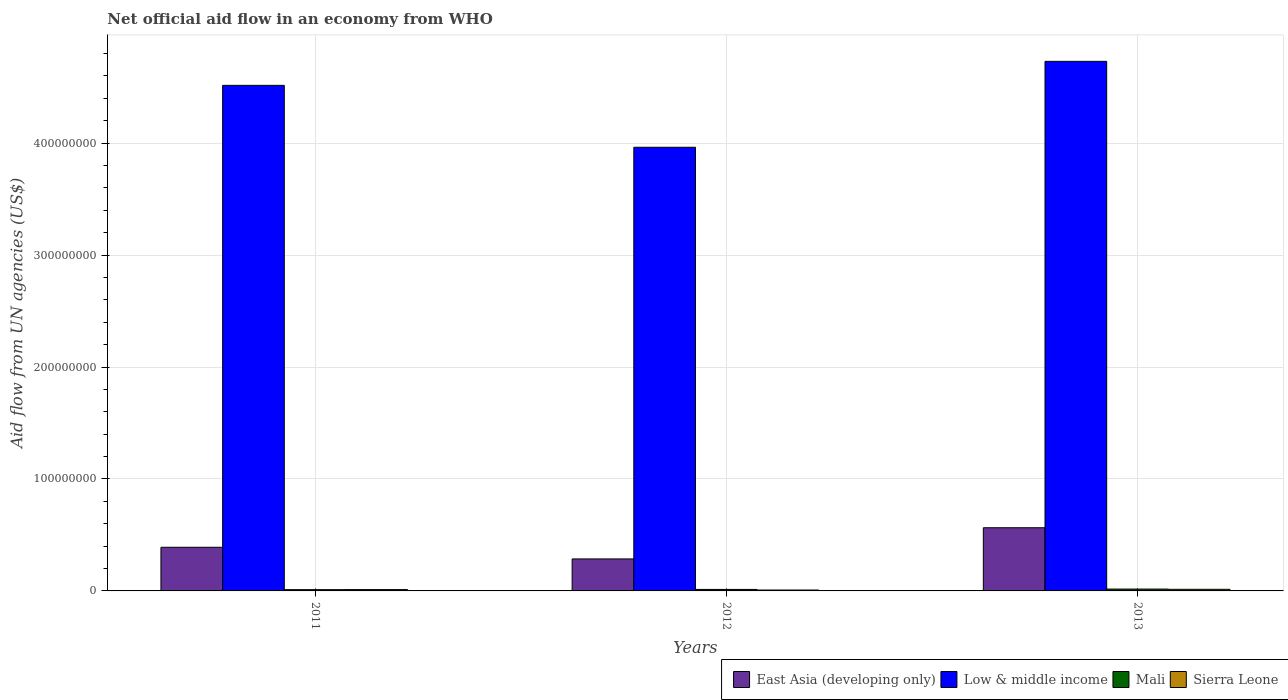How many groups of bars are there?
Keep it short and to the point. 3. Are the number of bars on each tick of the X-axis equal?
Keep it short and to the point. Yes. How many bars are there on the 3rd tick from the right?
Ensure brevity in your answer.  4. What is the label of the 2nd group of bars from the left?
Your response must be concise. 2012. What is the net official aid flow in Mali in 2012?
Make the answer very short. 1.33e+06. Across all years, what is the maximum net official aid flow in East Asia (developing only)?
Keep it short and to the point. 5.64e+07. Across all years, what is the minimum net official aid flow in Mali?
Provide a succinct answer. 1.13e+06. In which year was the net official aid flow in Sierra Leone maximum?
Provide a succinct answer. 2013. In which year was the net official aid flow in Low & middle income minimum?
Provide a short and direct response. 2012. What is the total net official aid flow in Low & middle income in the graph?
Your answer should be very brief. 1.32e+09. What is the difference between the net official aid flow in Mali in 2012 and that in 2013?
Offer a terse response. -3.30e+05. What is the difference between the net official aid flow in Mali in 2011 and the net official aid flow in East Asia (developing only) in 2012?
Ensure brevity in your answer.  -2.74e+07. What is the average net official aid flow in Low & middle income per year?
Ensure brevity in your answer.  4.40e+08. In the year 2013, what is the difference between the net official aid flow in Low & middle income and net official aid flow in East Asia (developing only)?
Keep it short and to the point. 4.17e+08. In how many years, is the net official aid flow in Sierra Leone greater than 400000000 US$?
Keep it short and to the point. 0. What is the ratio of the net official aid flow in East Asia (developing only) in 2011 to that in 2013?
Keep it short and to the point. 0.69. Is the net official aid flow in East Asia (developing only) in 2012 less than that in 2013?
Give a very brief answer. Yes. What is the difference between the highest and the second highest net official aid flow in Low & middle income?
Give a very brief answer. 2.14e+07. What is the difference between the highest and the lowest net official aid flow in Sierra Leone?
Ensure brevity in your answer.  6.40e+05. In how many years, is the net official aid flow in Sierra Leone greater than the average net official aid flow in Sierra Leone taken over all years?
Ensure brevity in your answer.  2. Is the sum of the net official aid flow in Low & middle income in 2011 and 2013 greater than the maximum net official aid flow in Mali across all years?
Make the answer very short. Yes. What does the 4th bar from the left in 2011 represents?
Offer a very short reply. Sierra Leone. What does the 4th bar from the right in 2012 represents?
Your response must be concise. East Asia (developing only). What is the difference between two consecutive major ticks on the Y-axis?
Ensure brevity in your answer.  1.00e+08. Does the graph contain any zero values?
Ensure brevity in your answer.  No. Does the graph contain grids?
Make the answer very short. Yes. How many legend labels are there?
Keep it short and to the point. 4. How are the legend labels stacked?
Make the answer very short. Horizontal. What is the title of the graph?
Provide a short and direct response. Net official aid flow in an economy from WHO. What is the label or title of the Y-axis?
Offer a terse response. Aid flow from UN agencies (US$). What is the Aid flow from UN agencies (US$) of East Asia (developing only) in 2011?
Provide a succinct answer. 3.90e+07. What is the Aid flow from UN agencies (US$) of Low & middle income in 2011?
Your response must be concise. 4.52e+08. What is the Aid flow from UN agencies (US$) of Mali in 2011?
Your answer should be very brief. 1.13e+06. What is the Aid flow from UN agencies (US$) of Sierra Leone in 2011?
Provide a short and direct response. 1.19e+06. What is the Aid flow from UN agencies (US$) of East Asia (developing only) in 2012?
Your response must be concise. 2.86e+07. What is the Aid flow from UN agencies (US$) of Low & middle income in 2012?
Keep it short and to the point. 3.96e+08. What is the Aid flow from UN agencies (US$) of Mali in 2012?
Your answer should be compact. 1.33e+06. What is the Aid flow from UN agencies (US$) of East Asia (developing only) in 2013?
Your answer should be compact. 5.64e+07. What is the Aid flow from UN agencies (US$) of Low & middle income in 2013?
Your response must be concise. 4.73e+08. What is the Aid flow from UN agencies (US$) in Mali in 2013?
Your answer should be very brief. 1.66e+06. What is the Aid flow from UN agencies (US$) of Sierra Leone in 2013?
Your response must be concise. 1.44e+06. Across all years, what is the maximum Aid flow from UN agencies (US$) of East Asia (developing only)?
Give a very brief answer. 5.64e+07. Across all years, what is the maximum Aid flow from UN agencies (US$) in Low & middle income?
Ensure brevity in your answer.  4.73e+08. Across all years, what is the maximum Aid flow from UN agencies (US$) in Mali?
Keep it short and to the point. 1.66e+06. Across all years, what is the maximum Aid flow from UN agencies (US$) in Sierra Leone?
Ensure brevity in your answer.  1.44e+06. Across all years, what is the minimum Aid flow from UN agencies (US$) of East Asia (developing only)?
Offer a terse response. 2.86e+07. Across all years, what is the minimum Aid flow from UN agencies (US$) in Low & middle income?
Your response must be concise. 3.96e+08. Across all years, what is the minimum Aid flow from UN agencies (US$) of Mali?
Give a very brief answer. 1.13e+06. Across all years, what is the minimum Aid flow from UN agencies (US$) of Sierra Leone?
Keep it short and to the point. 8.00e+05. What is the total Aid flow from UN agencies (US$) of East Asia (developing only) in the graph?
Offer a terse response. 1.24e+08. What is the total Aid flow from UN agencies (US$) in Low & middle income in the graph?
Provide a succinct answer. 1.32e+09. What is the total Aid flow from UN agencies (US$) of Mali in the graph?
Your answer should be compact. 4.12e+06. What is the total Aid flow from UN agencies (US$) of Sierra Leone in the graph?
Your answer should be very brief. 3.43e+06. What is the difference between the Aid flow from UN agencies (US$) of East Asia (developing only) in 2011 and that in 2012?
Offer a very short reply. 1.04e+07. What is the difference between the Aid flow from UN agencies (US$) in Low & middle income in 2011 and that in 2012?
Offer a terse response. 5.53e+07. What is the difference between the Aid flow from UN agencies (US$) of Mali in 2011 and that in 2012?
Your response must be concise. -2.00e+05. What is the difference between the Aid flow from UN agencies (US$) of Sierra Leone in 2011 and that in 2012?
Offer a very short reply. 3.90e+05. What is the difference between the Aid flow from UN agencies (US$) in East Asia (developing only) in 2011 and that in 2013?
Offer a very short reply. -1.74e+07. What is the difference between the Aid flow from UN agencies (US$) of Low & middle income in 2011 and that in 2013?
Provide a short and direct response. -2.14e+07. What is the difference between the Aid flow from UN agencies (US$) of Mali in 2011 and that in 2013?
Make the answer very short. -5.30e+05. What is the difference between the Aid flow from UN agencies (US$) of East Asia (developing only) in 2012 and that in 2013?
Your answer should be very brief. -2.78e+07. What is the difference between the Aid flow from UN agencies (US$) of Low & middle income in 2012 and that in 2013?
Provide a short and direct response. -7.67e+07. What is the difference between the Aid flow from UN agencies (US$) in Mali in 2012 and that in 2013?
Give a very brief answer. -3.30e+05. What is the difference between the Aid flow from UN agencies (US$) in Sierra Leone in 2012 and that in 2013?
Offer a terse response. -6.40e+05. What is the difference between the Aid flow from UN agencies (US$) in East Asia (developing only) in 2011 and the Aid flow from UN agencies (US$) in Low & middle income in 2012?
Give a very brief answer. -3.57e+08. What is the difference between the Aid flow from UN agencies (US$) of East Asia (developing only) in 2011 and the Aid flow from UN agencies (US$) of Mali in 2012?
Provide a short and direct response. 3.77e+07. What is the difference between the Aid flow from UN agencies (US$) of East Asia (developing only) in 2011 and the Aid flow from UN agencies (US$) of Sierra Leone in 2012?
Offer a terse response. 3.82e+07. What is the difference between the Aid flow from UN agencies (US$) in Low & middle income in 2011 and the Aid flow from UN agencies (US$) in Mali in 2012?
Your answer should be compact. 4.50e+08. What is the difference between the Aid flow from UN agencies (US$) in Low & middle income in 2011 and the Aid flow from UN agencies (US$) in Sierra Leone in 2012?
Make the answer very short. 4.51e+08. What is the difference between the Aid flow from UN agencies (US$) in East Asia (developing only) in 2011 and the Aid flow from UN agencies (US$) in Low & middle income in 2013?
Provide a short and direct response. -4.34e+08. What is the difference between the Aid flow from UN agencies (US$) of East Asia (developing only) in 2011 and the Aid flow from UN agencies (US$) of Mali in 2013?
Your answer should be compact. 3.73e+07. What is the difference between the Aid flow from UN agencies (US$) of East Asia (developing only) in 2011 and the Aid flow from UN agencies (US$) of Sierra Leone in 2013?
Give a very brief answer. 3.76e+07. What is the difference between the Aid flow from UN agencies (US$) of Low & middle income in 2011 and the Aid flow from UN agencies (US$) of Mali in 2013?
Offer a terse response. 4.50e+08. What is the difference between the Aid flow from UN agencies (US$) in Low & middle income in 2011 and the Aid flow from UN agencies (US$) in Sierra Leone in 2013?
Keep it short and to the point. 4.50e+08. What is the difference between the Aid flow from UN agencies (US$) in Mali in 2011 and the Aid flow from UN agencies (US$) in Sierra Leone in 2013?
Provide a short and direct response. -3.10e+05. What is the difference between the Aid flow from UN agencies (US$) of East Asia (developing only) in 2012 and the Aid flow from UN agencies (US$) of Low & middle income in 2013?
Keep it short and to the point. -4.44e+08. What is the difference between the Aid flow from UN agencies (US$) in East Asia (developing only) in 2012 and the Aid flow from UN agencies (US$) in Mali in 2013?
Your answer should be compact. 2.69e+07. What is the difference between the Aid flow from UN agencies (US$) in East Asia (developing only) in 2012 and the Aid flow from UN agencies (US$) in Sierra Leone in 2013?
Your answer should be very brief. 2.71e+07. What is the difference between the Aid flow from UN agencies (US$) of Low & middle income in 2012 and the Aid flow from UN agencies (US$) of Mali in 2013?
Your response must be concise. 3.95e+08. What is the difference between the Aid flow from UN agencies (US$) of Low & middle income in 2012 and the Aid flow from UN agencies (US$) of Sierra Leone in 2013?
Provide a short and direct response. 3.95e+08. What is the difference between the Aid flow from UN agencies (US$) of Mali in 2012 and the Aid flow from UN agencies (US$) of Sierra Leone in 2013?
Keep it short and to the point. -1.10e+05. What is the average Aid flow from UN agencies (US$) in East Asia (developing only) per year?
Give a very brief answer. 4.13e+07. What is the average Aid flow from UN agencies (US$) in Low & middle income per year?
Provide a short and direct response. 4.40e+08. What is the average Aid flow from UN agencies (US$) of Mali per year?
Your answer should be very brief. 1.37e+06. What is the average Aid flow from UN agencies (US$) in Sierra Leone per year?
Give a very brief answer. 1.14e+06. In the year 2011, what is the difference between the Aid flow from UN agencies (US$) of East Asia (developing only) and Aid flow from UN agencies (US$) of Low & middle income?
Your answer should be compact. -4.13e+08. In the year 2011, what is the difference between the Aid flow from UN agencies (US$) in East Asia (developing only) and Aid flow from UN agencies (US$) in Mali?
Your answer should be very brief. 3.79e+07. In the year 2011, what is the difference between the Aid flow from UN agencies (US$) of East Asia (developing only) and Aid flow from UN agencies (US$) of Sierra Leone?
Give a very brief answer. 3.78e+07. In the year 2011, what is the difference between the Aid flow from UN agencies (US$) of Low & middle income and Aid flow from UN agencies (US$) of Mali?
Your response must be concise. 4.50e+08. In the year 2011, what is the difference between the Aid flow from UN agencies (US$) of Low & middle income and Aid flow from UN agencies (US$) of Sierra Leone?
Provide a succinct answer. 4.50e+08. In the year 2012, what is the difference between the Aid flow from UN agencies (US$) in East Asia (developing only) and Aid flow from UN agencies (US$) in Low & middle income?
Provide a succinct answer. -3.68e+08. In the year 2012, what is the difference between the Aid flow from UN agencies (US$) of East Asia (developing only) and Aid flow from UN agencies (US$) of Mali?
Provide a short and direct response. 2.72e+07. In the year 2012, what is the difference between the Aid flow from UN agencies (US$) of East Asia (developing only) and Aid flow from UN agencies (US$) of Sierra Leone?
Give a very brief answer. 2.78e+07. In the year 2012, what is the difference between the Aid flow from UN agencies (US$) of Low & middle income and Aid flow from UN agencies (US$) of Mali?
Your answer should be compact. 3.95e+08. In the year 2012, what is the difference between the Aid flow from UN agencies (US$) in Low & middle income and Aid flow from UN agencies (US$) in Sierra Leone?
Offer a very short reply. 3.95e+08. In the year 2012, what is the difference between the Aid flow from UN agencies (US$) of Mali and Aid flow from UN agencies (US$) of Sierra Leone?
Your response must be concise. 5.30e+05. In the year 2013, what is the difference between the Aid flow from UN agencies (US$) of East Asia (developing only) and Aid flow from UN agencies (US$) of Low & middle income?
Give a very brief answer. -4.17e+08. In the year 2013, what is the difference between the Aid flow from UN agencies (US$) in East Asia (developing only) and Aid flow from UN agencies (US$) in Mali?
Make the answer very short. 5.48e+07. In the year 2013, what is the difference between the Aid flow from UN agencies (US$) in East Asia (developing only) and Aid flow from UN agencies (US$) in Sierra Leone?
Your answer should be compact. 5.50e+07. In the year 2013, what is the difference between the Aid flow from UN agencies (US$) in Low & middle income and Aid flow from UN agencies (US$) in Mali?
Your response must be concise. 4.71e+08. In the year 2013, what is the difference between the Aid flow from UN agencies (US$) in Low & middle income and Aid flow from UN agencies (US$) in Sierra Leone?
Give a very brief answer. 4.72e+08. In the year 2013, what is the difference between the Aid flow from UN agencies (US$) in Mali and Aid flow from UN agencies (US$) in Sierra Leone?
Keep it short and to the point. 2.20e+05. What is the ratio of the Aid flow from UN agencies (US$) of East Asia (developing only) in 2011 to that in 2012?
Ensure brevity in your answer.  1.36. What is the ratio of the Aid flow from UN agencies (US$) of Low & middle income in 2011 to that in 2012?
Ensure brevity in your answer.  1.14. What is the ratio of the Aid flow from UN agencies (US$) in Mali in 2011 to that in 2012?
Ensure brevity in your answer.  0.85. What is the ratio of the Aid flow from UN agencies (US$) of Sierra Leone in 2011 to that in 2012?
Give a very brief answer. 1.49. What is the ratio of the Aid flow from UN agencies (US$) in East Asia (developing only) in 2011 to that in 2013?
Make the answer very short. 0.69. What is the ratio of the Aid flow from UN agencies (US$) of Low & middle income in 2011 to that in 2013?
Provide a succinct answer. 0.95. What is the ratio of the Aid flow from UN agencies (US$) in Mali in 2011 to that in 2013?
Offer a terse response. 0.68. What is the ratio of the Aid flow from UN agencies (US$) of Sierra Leone in 2011 to that in 2013?
Provide a succinct answer. 0.83. What is the ratio of the Aid flow from UN agencies (US$) of East Asia (developing only) in 2012 to that in 2013?
Offer a very short reply. 0.51. What is the ratio of the Aid flow from UN agencies (US$) of Low & middle income in 2012 to that in 2013?
Provide a succinct answer. 0.84. What is the ratio of the Aid flow from UN agencies (US$) of Mali in 2012 to that in 2013?
Your answer should be compact. 0.8. What is the ratio of the Aid flow from UN agencies (US$) of Sierra Leone in 2012 to that in 2013?
Offer a terse response. 0.56. What is the difference between the highest and the second highest Aid flow from UN agencies (US$) of East Asia (developing only)?
Provide a short and direct response. 1.74e+07. What is the difference between the highest and the second highest Aid flow from UN agencies (US$) of Low & middle income?
Your answer should be compact. 2.14e+07. What is the difference between the highest and the second highest Aid flow from UN agencies (US$) in Mali?
Make the answer very short. 3.30e+05. What is the difference between the highest and the second highest Aid flow from UN agencies (US$) of Sierra Leone?
Provide a succinct answer. 2.50e+05. What is the difference between the highest and the lowest Aid flow from UN agencies (US$) of East Asia (developing only)?
Offer a terse response. 2.78e+07. What is the difference between the highest and the lowest Aid flow from UN agencies (US$) in Low & middle income?
Offer a terse response. 7.67e+07. What is the difference between the highest and the lowest Aid flow from UN agencies (US$) in Mali?
Keep it short and to the point. 5.30e+05. What is the difference between the highest and the lowest Aid flow from UN agencies (US$) in Sierra Leone?
Your answer should be compact. 6.40e+05. 